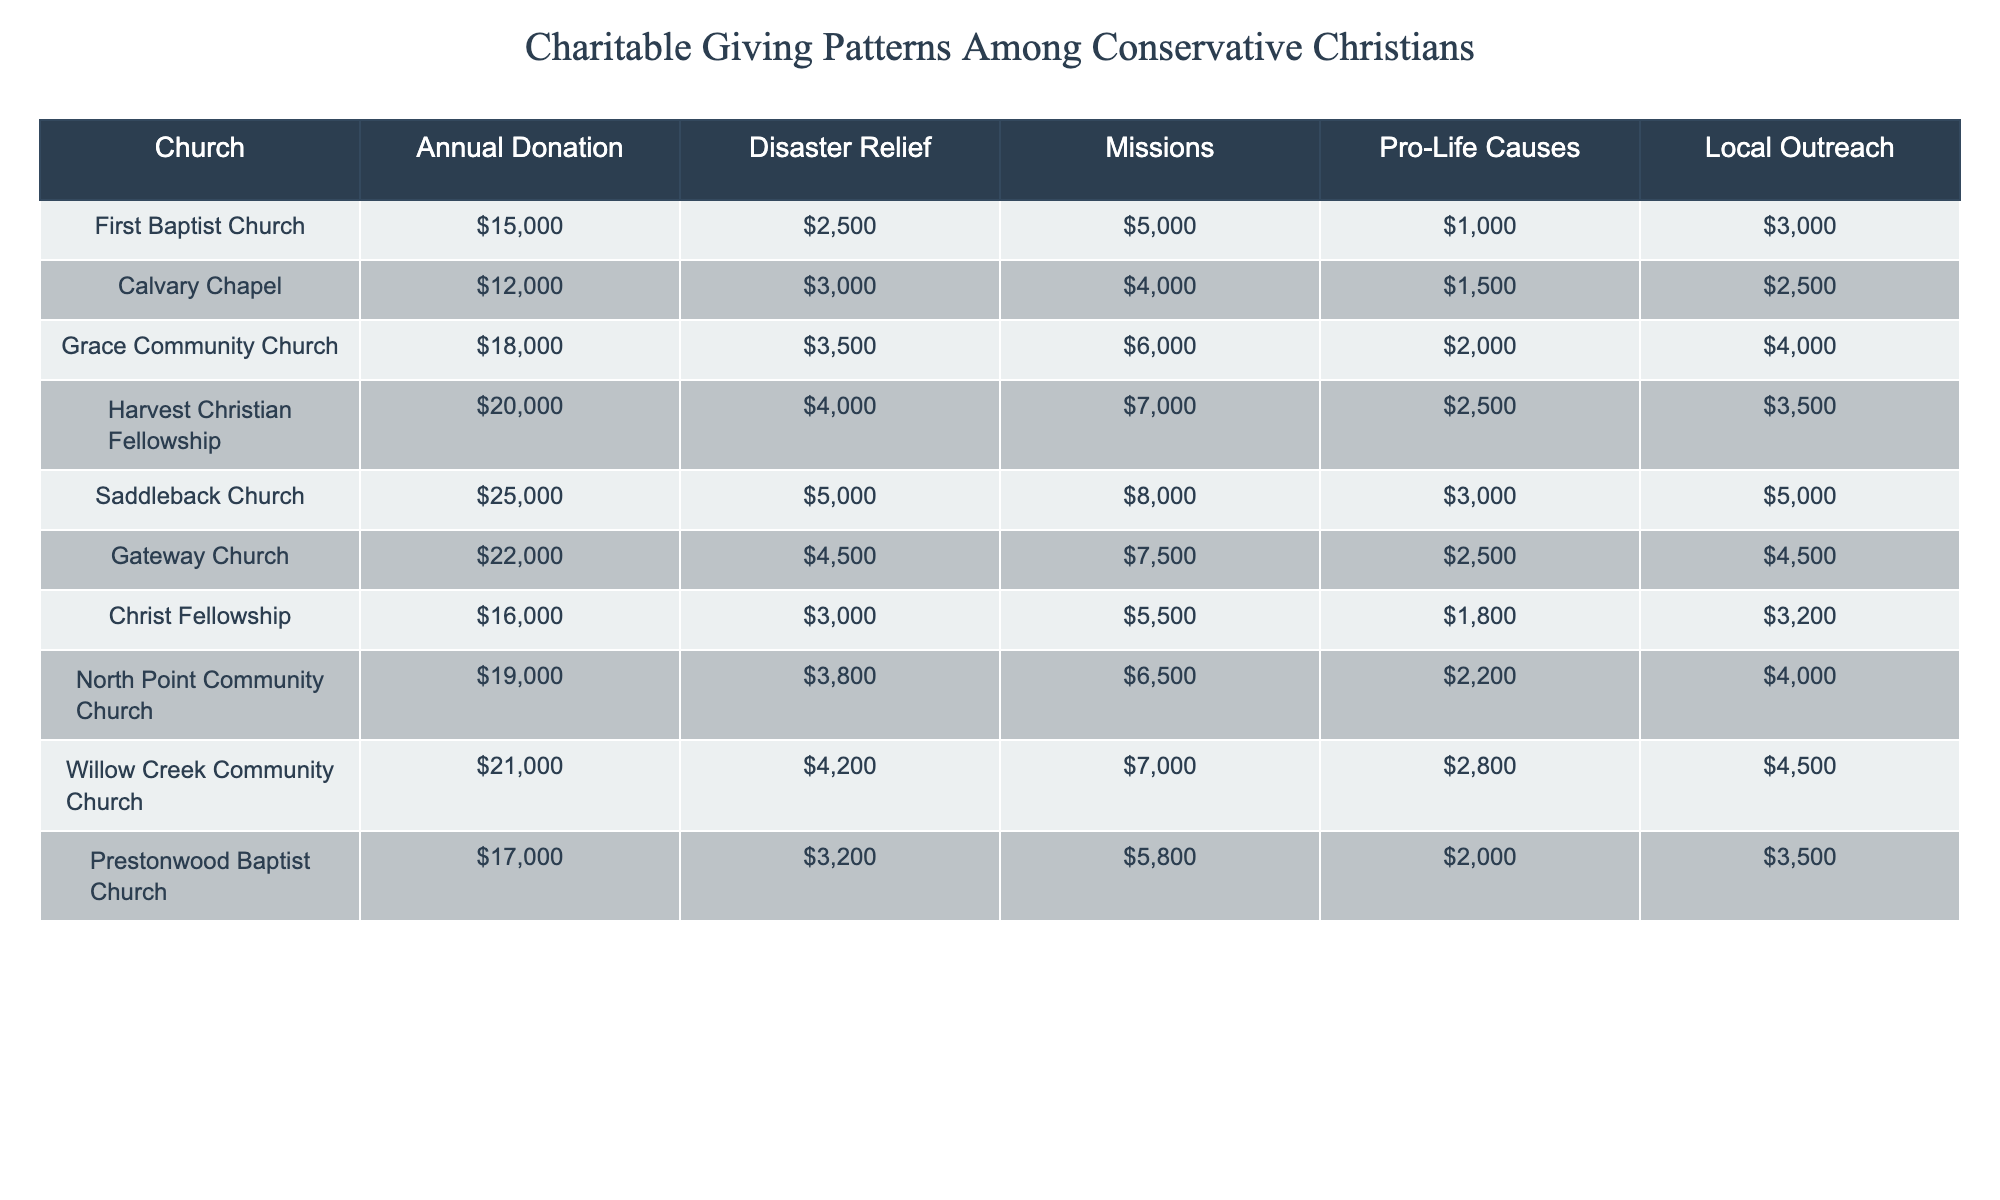What is the total annual donation for Saddleback Church? The information in the table shows that Saddleback Church has an annual donation of $25,000.
Answer: $25,000 Which church provided the highest amount for disaster relief? By checking the disaster relief column, the highest value is $5,000, which is provided by Saddleback Church.
Answer: Saddleback Church What is the average amount donated to pro-life causes across all churches? To calculate the average, sum all the pro-life cause donations: 1000 + 1500 + 2000 + 2500 + 3000 + 2500 + 1800 + 2200 + 2800 + 2000 = 20,500. Then divide by the number of churches (10): 20,500 / 10 = 2,050.
Answer: $2,050 Is the total annual donation of Grace Community Church greater than the total from North Point Community Church? Grace Community Church has an annual donation of $18,000, while North Point Community Church has $19,000. Thus, Grace's donation is less than North Point's.
Answer: No What is the total amount donated to missions by all churches combined? Adding all the missions donations: 5000 + 4000 + 6000 + 7000 + 8000 + 7500 + 5500 + 6500 + 7000 + 5800 = 60,000.
Answer: $60,000 Which church has a larger sum of donations for disaster relief and local outreach combined? For disaster relief and local outreach combined: For example, Saddleback Church has $5,000 (disaster relief) + $5,000 (local outreach) = $10,000. Performing this calculation for all churches shows that Saddleback has the largest total.
Answer: Saddleback Church What percentage of the annual donation of First Baptist Church is allocated to missions? First Baptist Church's annual donation is $15,000, and missions donations are $5,000. The percentage is calculated as (5000 / 15000) * 100 = 33.33%.
Answer: 33.33% Which church has the smallest total donation to local outreach? Checking the local outreach column, the lowest value is $2,500 from Calvary Chapel.
Answer: Calvary Chapel What is the difference between the annual donations of Willow Creek Community Church and Christ Fellowship? Willow Creek has an annual donation of $21,000, while Christ Fellowship has $16,000. The difference is $21,000 - $16,000 = $5,000.
Answer: $5,000 Are more churches donating over $20,000 annually than those below that amount? By counting, there are 4 churches with donations over $20,000 (Saddleback, Gateway, and Harvest Christian Fellowship). There are 6 churches below that amount. Therefore, more churches are below $20,000.
Answer: No 